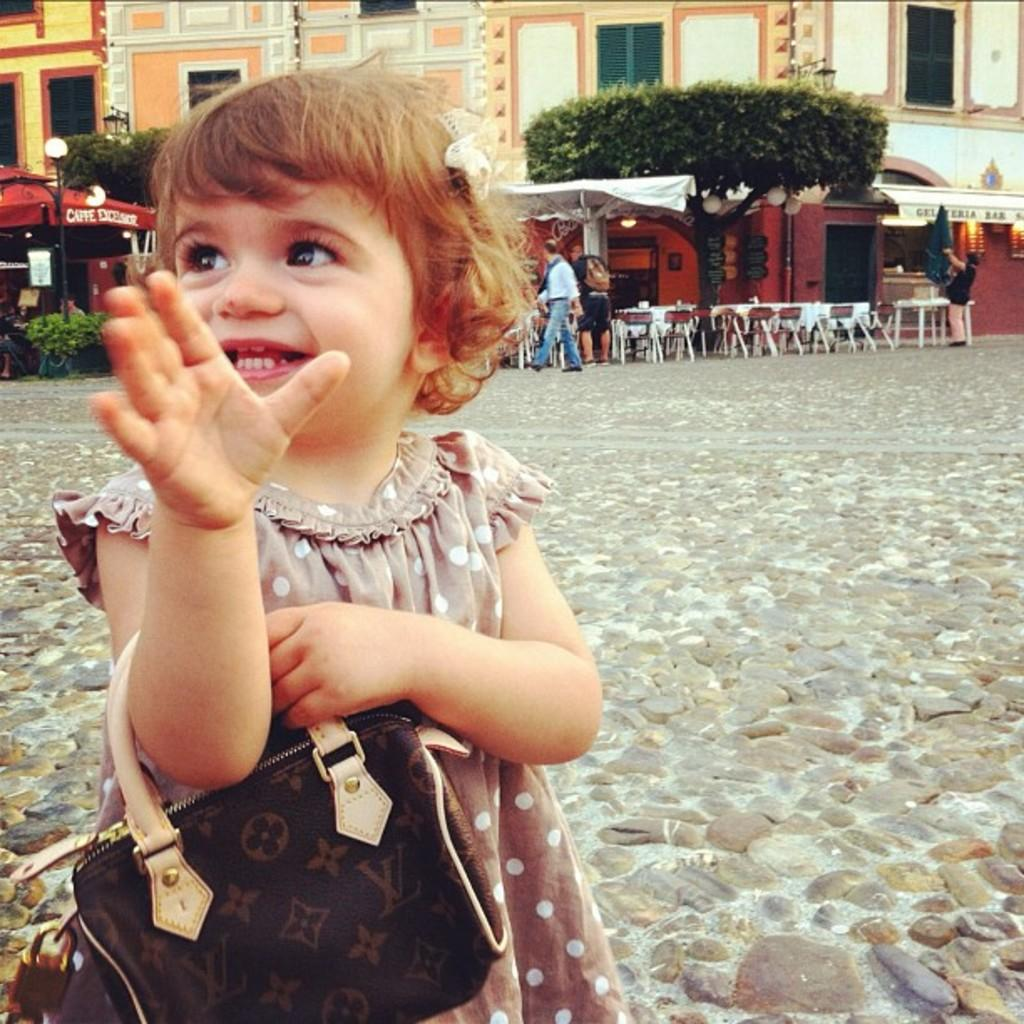Who is present in the image? There is a girl in the image. What is the girl wearing? The girl is wearing a handbag. What type of furniture can be seen in the image? There are chairs and tables in the image. What natural element is visible in the image? There is a tree in the image. What man-made structure is present in the image? There is a building in the image. Are there any other people besides the girl in the image? Yes, there are people in the image. What type of silk is draped over the branch in the image? There is no silk or branch present in the image. What causes the shock in the image? There is no shock or indication of any electrical activity in the image. 